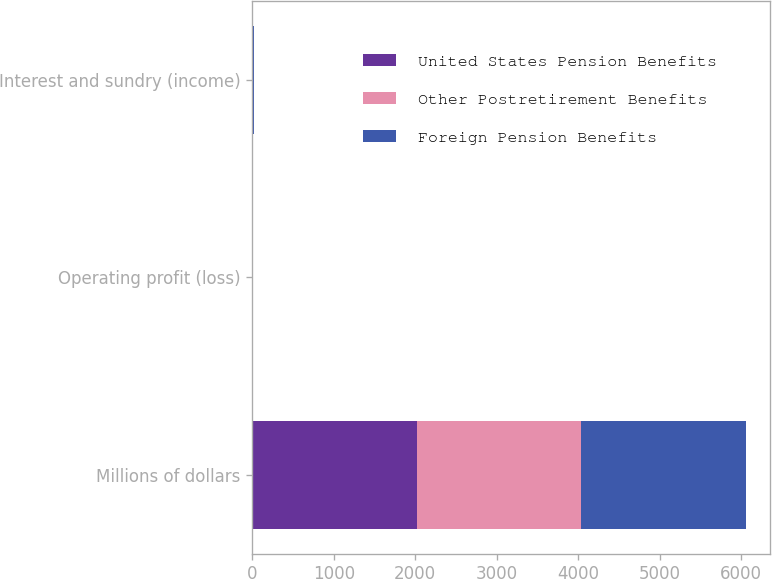Convert chart. <chart><loc_0><loc_0><loc_500><loc_500><stacked_bar_chart><ecel><fcel>Millions of dollars<fcel>Operating profit (loss)<fcel>Interest and sundry (income)<nl><fcel>United States Pension Benefits<fcel>2018<fcel>2<fcel>2<nl><fcel>Other Postretirement Benefits<fcel>2018<fcel>5<fcel>1<nl><fcel>Foreign Pension Benefits<fcel>2018<fcel>7<fcel>15<nl></chart> 